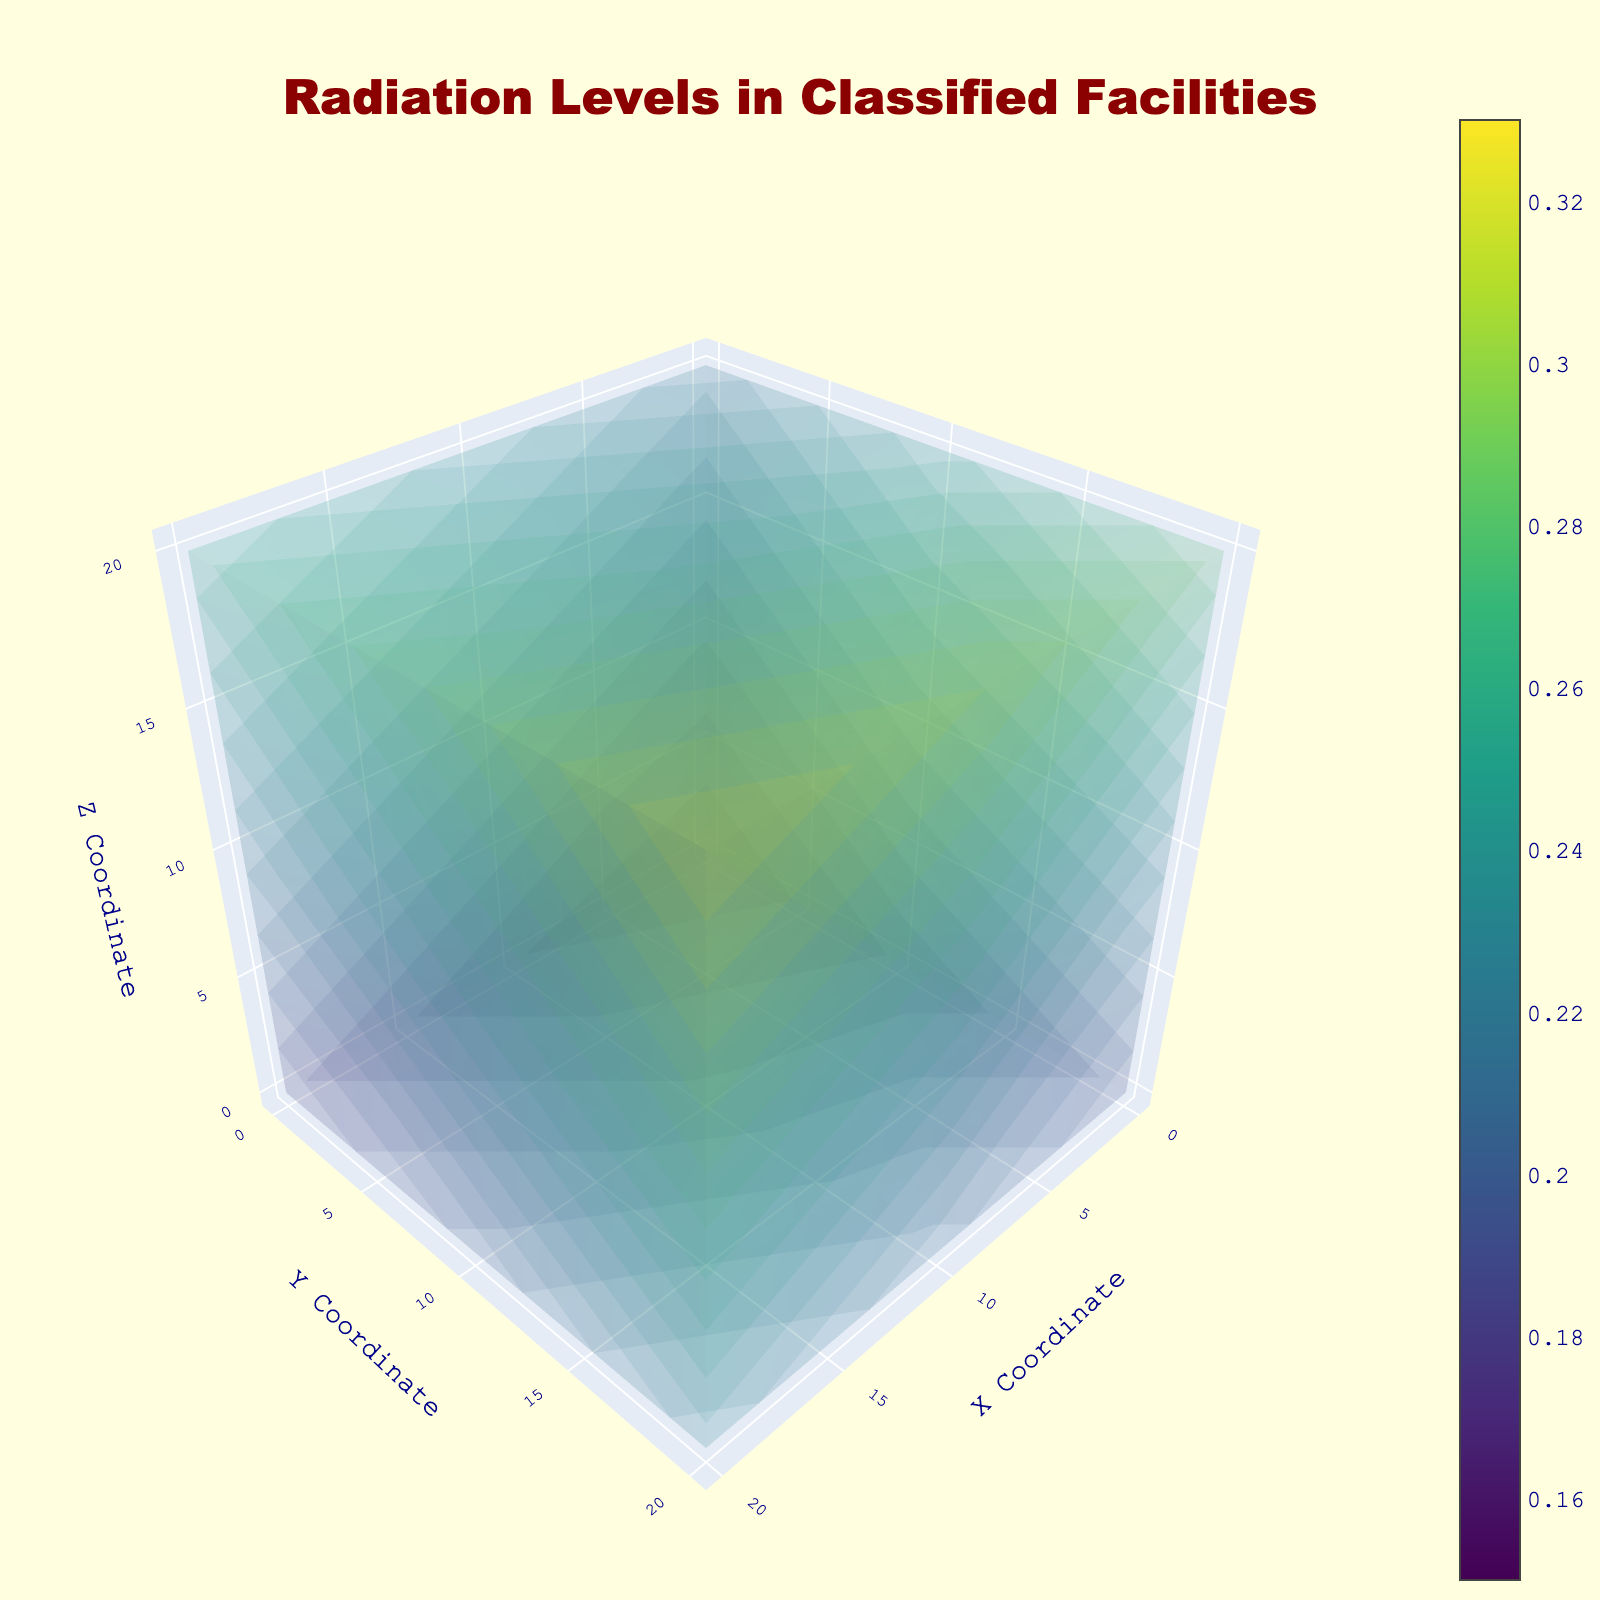what is the title of the plot? The title of the plot is displayed at the center-top of the figure. It provides a brief description of what the plot represents.
Answer: Radiation Levels in Classified Facilities what are the units used for the x, y, and z axes? The units for the x, y, and z axes are provided in their respective axis titles. Each axis is labeled with a coordinate, implying units of distance.
Answer: X Coordinate, Y Coordinate, Z Coordinate What is the range of radiation levels displayed in the plot? The range of radiation levels can be determined by looking at the color scale bar in the plot, which indicates the minimum and maximum values.
Answer: 0.15 to 0.33 Where in the plot is the maximum radiation level located? The maximum radiation level corresponds to the highest value in the color scale, and it can be identified by locating the darkest color in accordance with the Viridis colorscale. According to the data, 20,20,20 has the maximum radiation level of 0.33.
Answer: (20, 20, 20) Considering the radius range, what is the average value of radiation levels? To find the average radiation level, sum up all the radiation levels provided and then divide by the number of data points. (0.15 + 0.18 + 0.22 + 0.17 + 0.21 + 0.25 + 0.19 + 0.23 + 0.28 + 0.16 + 0.20 + 0.24 + 0.18 + 0.23 + 0.27 + 0.21 + 0.26 + 0.31 + 0.18 + 0.22 + 0.26 + 0.20 + 0.25 + 0.29 + 0.23 + 0.28 + 0.33) / 27 = 0.231
Answer: 0.231 